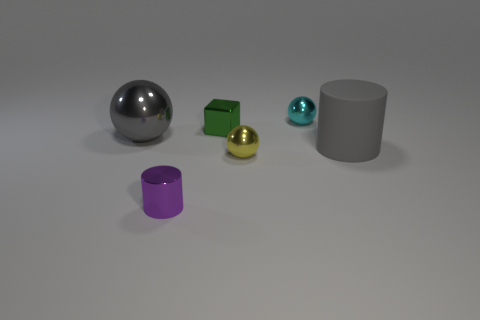What shape is the green shiny object? cube 